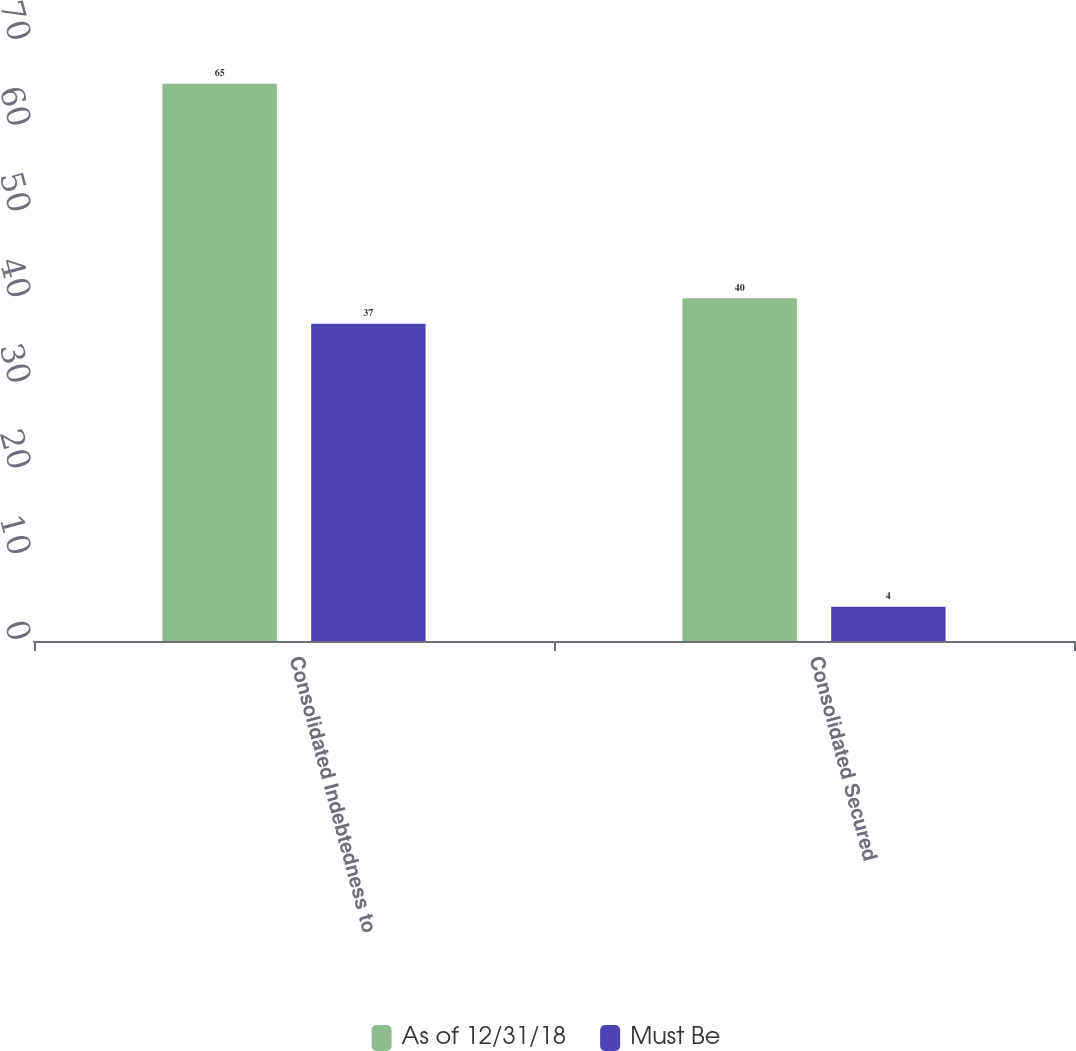<chart> <loc_0><loc_0><loc_500><loc_500><stacked_bar_chart><ecel><fcel>Consolidated Indebtedness to<fcel>Consolidated Secured<nl><fcel>As of 12/31/18<fcel>65<fcel>40<nl><fcel>Must Be<fcel>37<fcel>4<nl></chart> 